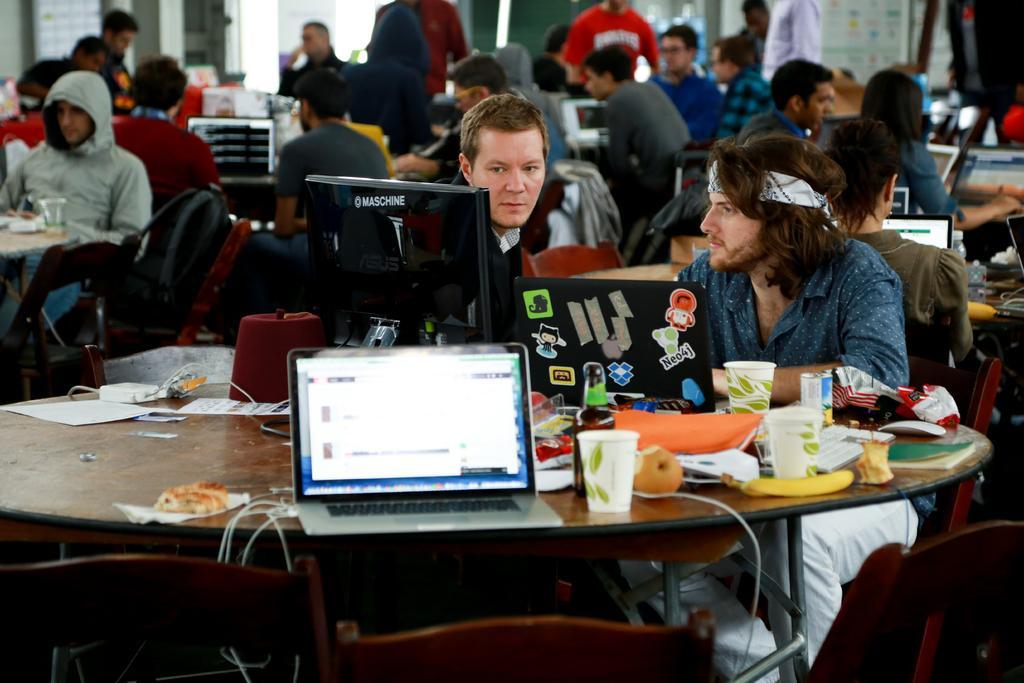How would you summarize this image in a sentence or two? Here we can see some persons are sitting on the chairs. These are the tables. On the table there are laptops, glasses, and papers. On the background there is a wall. 